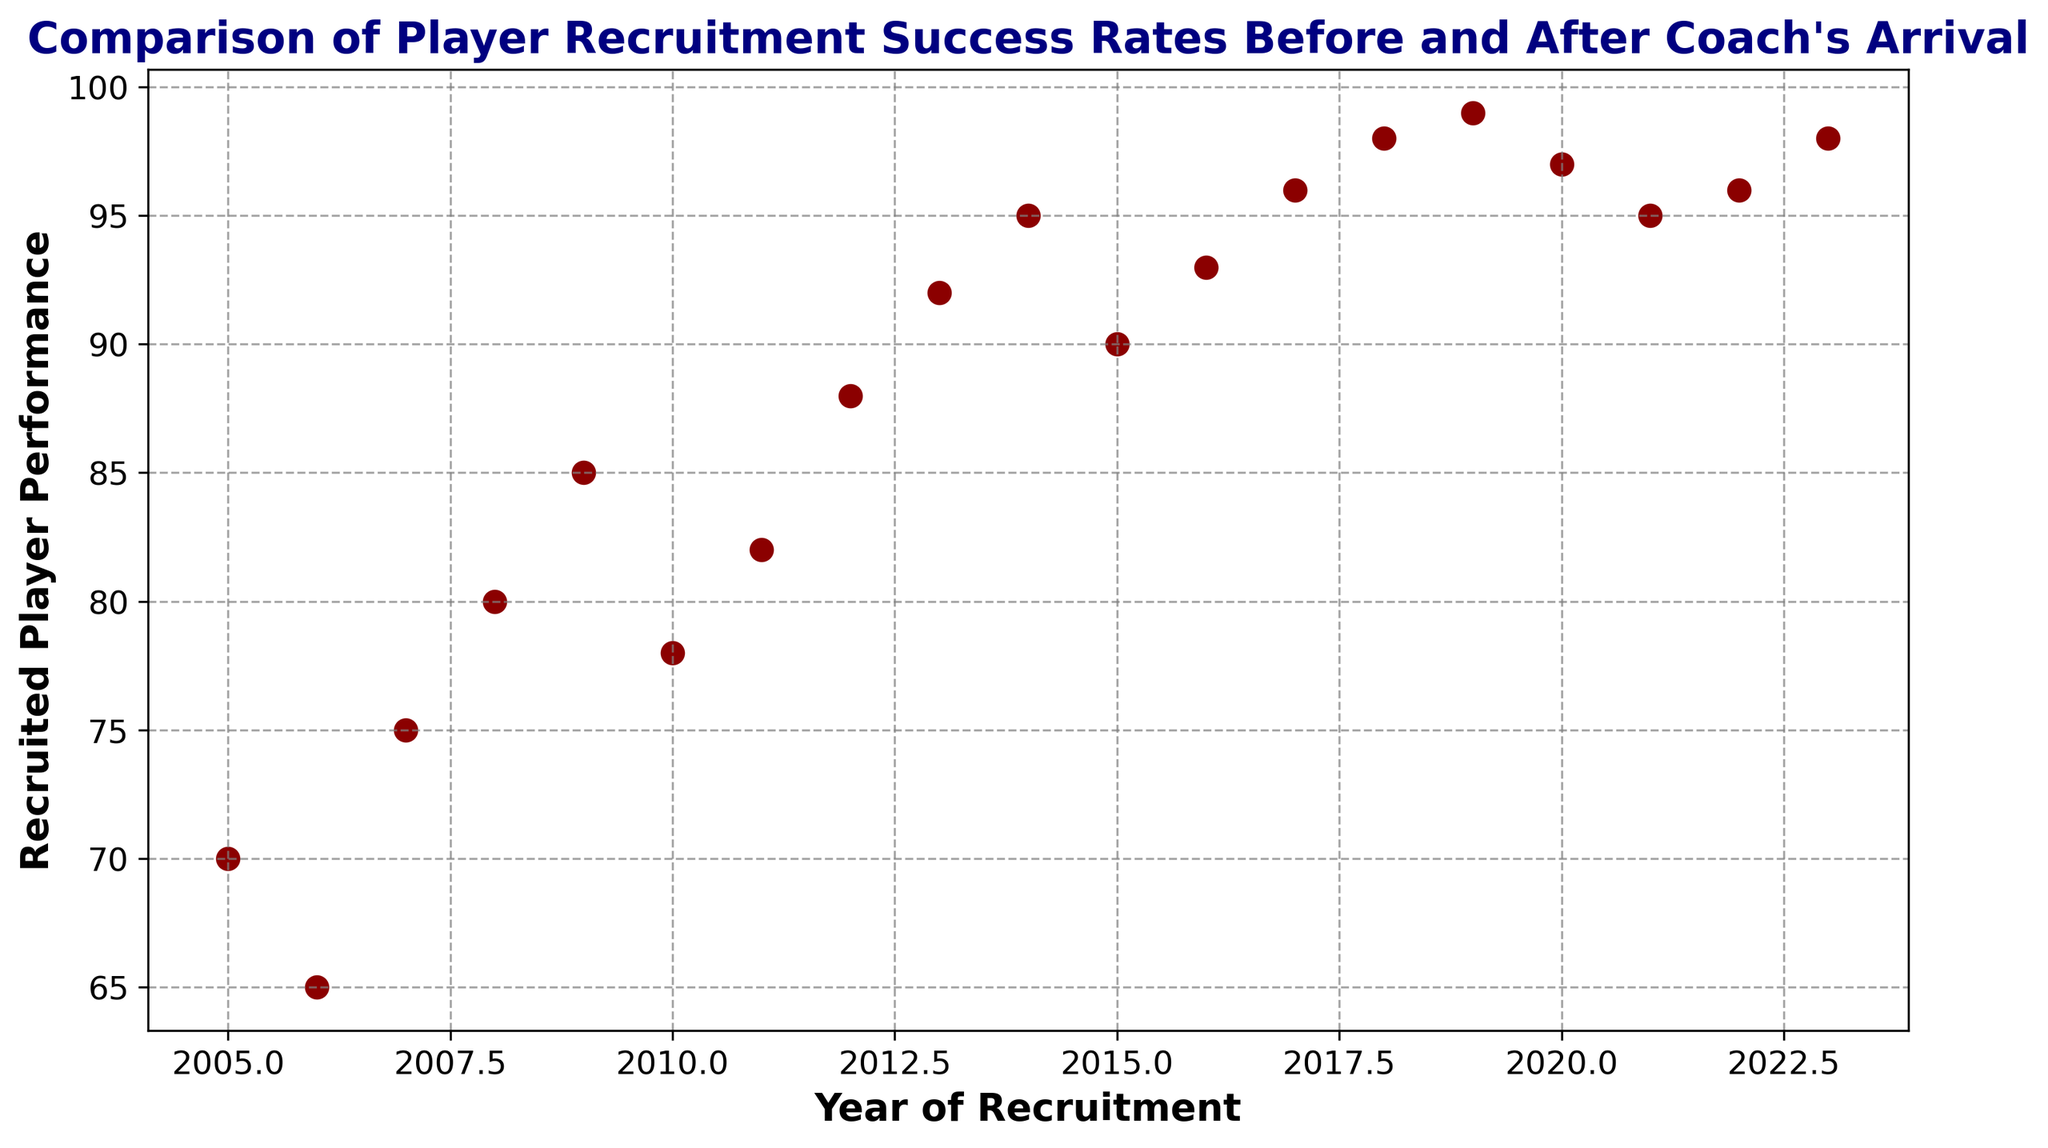What year witnessed the highest player performance? Looking at the scatter plot, the highest point is recorded for the year 2019 indicating the peak performance.
Answer: 2019 How did the player's performance change from 2013 to 2015? In 2013, the performance was 92. It increased slightly to 95 in 2014 and decreased to 90 in 2015. The change is an initial increase followed by a decrease.
Answer: Initial increase, then decrease Compare the player performance in the year 2018 with 2022. Which year had higher performance? The scatter plot shows that the year 2018 reached a performance value of 98. Similarly, in 2022, the performance was 96. Therefore, 2018 had the higher value.
Answer: 2018 How many years show a performance greater than or equal to 95? Reviewing the scatter plot, the years with a performance of 95 or greater are 2014 (95), 2016 (93), 2017 (96), 2018 (98), 2019 (99), 2020 (97), 2021 (95), 2022 (96), and 2023 (98). There are 9 such years.
Answer: 9 Which year shows the lowest performance value observed after the coach's arrival? Assuming the coach arrived in 2010, the lowest performance thereafter is 78 in 2010 itself. All subsequent years show higher values.
Answer: 2010 What is the average player performance from 2008 to 2010? The performances from 2008 to 2010 are 80, 85, and 78 respectively. Summing these is 80 + 85 + 78 = 243. The average is 243 / 3 = 81.
Answer: 81 How did the trend of player performance change pre and post-2010? Before 2010, the performance showed gradual improvements from 70 in 2005 to 85 in 2009. Post-2010, the performance consistently increased, peaking at 99 in 2019 and slightly fluctuating afterward.
Answer: Gradual rise before 2010, consistent rise after If you were to draw a line of best fit, would it have a positive or negative slope? Observing the scatter plot, there is a general upward trend from 2005 to 2023 indicating that over the years, player performance has generally increased. Hence, the line of best fit would have a positive slope.
Answer: Positive Calculate the mean player performance from 2017 to 2020. The performances from 2017 to 2020 are 96, 98, 99, and 97 respectively. Summing these values gives 96 + 98 + 99 + 97 = 390. The mean is 390 / 4 = 97.5.
Answer: 97.5 Identify any outliers in the player performance data. Examining the scatter plot, all points seem to follow a consistent upward trend without any significant deviation from the pattern, indicating there are no evident outliers.
Answer: No outliers 